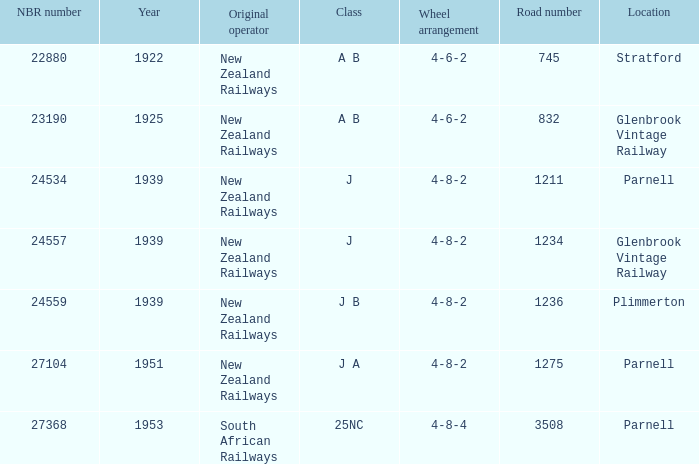What is the highest NBR number that corresponds to the J class and the road number of 1211? 24534.0. 